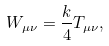<formula> <loc_0><loc_0><loc_500><loc_500>W _ { \mu \nu } = \frac { k } { 4 } T _ { \mu \nu } ,</formula> 